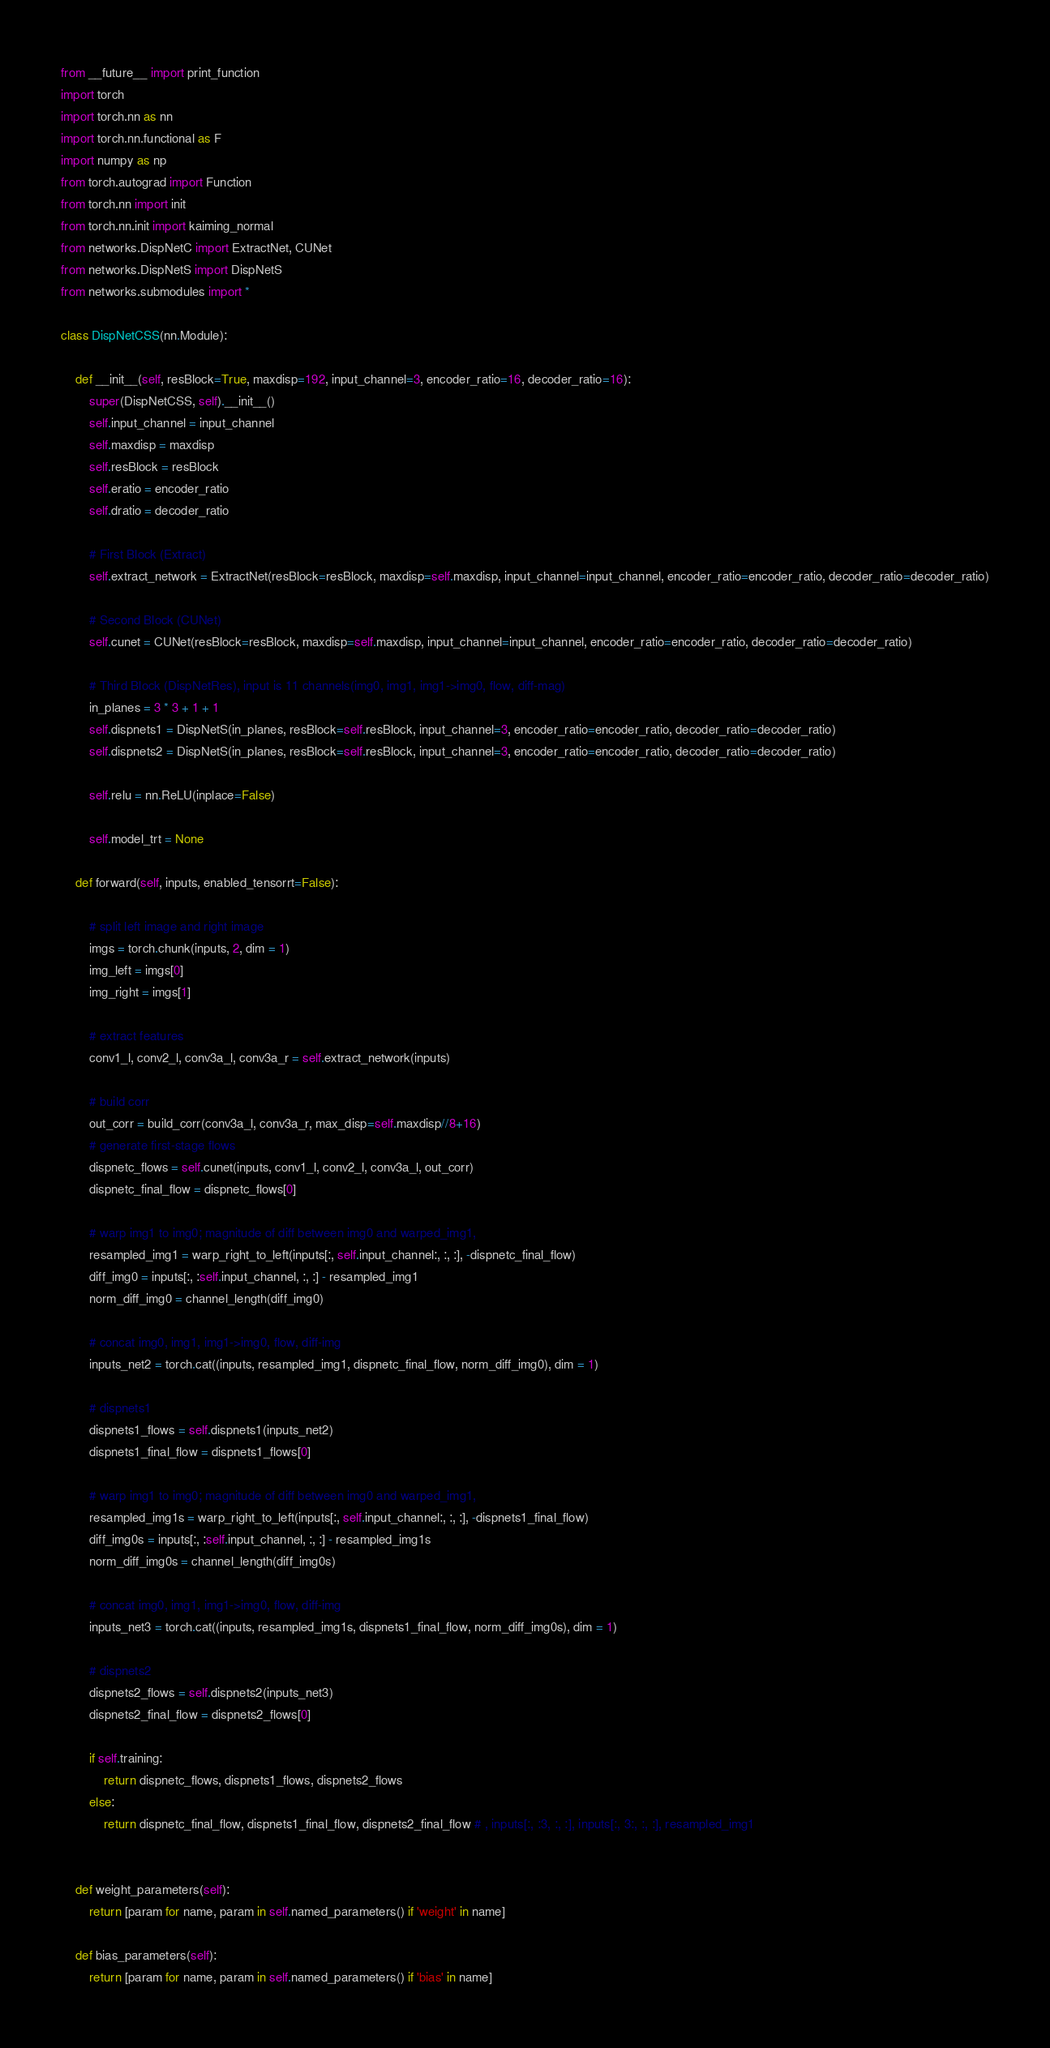Convert code to text. <code><loc_0><loc_0><loc_500><loc_500><_Python_>from __future__ import print_function
import torch
import torch.nn as nn
import torch.nn.functional as F
import numpy as np
from torch.autograd import Function
from torch.nn import init
from torch.nn.init import kaiming_normal
from networks.DispNetC import ExtractNet, CUNet
from networks.DispNetS import DispNetS
from networks.submodules import *

class DispNetCSS(nn.Module):

    def __init__(self, resBlock=True, maxdisp=192, input_channel=3, encoder_ratio=16, decoder_ratio=16):
        super(DispNetCSS, self).__init__()
        self.input_channel = input_channel
        self.maxdisp = maxdisp
        self.resBlock = resBlock
        self.eratio = encoder_ratio
        self.dratio = decoder_ratio

        # First Block (Extract)
        self.extract_network = ExtractNet(resBlock=resBlock, maxdisp=self.maxdisp, input_channel=input_channel, encoder_ratio=encoder_ratio, decoder_ratio=decoder_ratio)

        # Second Block (CUNet)
        self.cunet = CUNet(resBlock=resBlock, maxdisp=self.maxdisp, input_channel=input_channel, encoder_ratio=encoder_ratio, decoder_ratio=decoder_ratio)

        # Third Block (DispNetRes), input is 11 channels(img0, img1, img1->img0, flow, diff-mag)
        in_planes = 3 * 3 + 1 + 1
        self.dispnets1 = DispNetS(in_planes, resBlock=self.resBlock, input_channel=3, encoder_ratio=encoder_ratio, decoder_ratio=decoder_ratio)
        self.dispnets2 = DispNetS(in_planes, resBlock=self.resBlock, input_channel=3, encoder_ratio=encoder_ratio, decoder_ratio=decoder_ratio)

        self.relu = nn.ReLU(inplace=False)

        self.model_trt = None

    def forward(self, inputs, enabled_tensorrt=False):

        # split left image and right image
        imgs = torch.chunk(inputs, 2, dim = 1)
        img_left = imgs[0]
        img_right = imgs[1]

        # extract features
        conv1_l, conv2_l, conv3a_l, conv3a_r = self.extract_network(inputs)

        # build corr
        out_corr = build_corr(conv3a_l, conv3a_r, max_disp=self.maxdisp//8+16)
        # generate first-stage flows
        dispnetc_flows = self.cunet(inputs, conv1_l, conv2_l, conv3a_l, out_corr)
        dispnetc_final_flow = dispnetc_flows[0]

        # warp img1 to img0; magnitude of diff between img0 and warped_img1,
        resampled_img1 = warp_right_to_left(inputs[:, self.input_channel:, :, :], -dispnetc_final_flow)
        diff_img0 = inputs[:, :self.input_channel, :, :] - resampled_img1
        norm_diff_img0 = channel_length(diff_img0)

        # concat img0, img1, img1->img0, flow, diff-img
        inputs_net2 = torch.cat((inputs, resampled_img1, dispnetc_final_flow, norm_diff_img0), dim = 1)

        # dispnets1
        dispnets1_flows = self.dispnets1(inputs_net2)
        dispnets1_final_flow = dispnets1_flows[0]

        # warp img1 to img0; magnitude of diff between img0 and warped_img1,
        resampled_img1s = warp_right_to_left(inputs[:, self.input_channel:, :, :], -dispnets1_final_flow)
        diff_img0s = inputs[:, :self.input_channel, :, :] - resampled_img1s
        norm_diff_img0s = channel_length(diff_img0s)

        # concat img0, img1, img1->img0, flow, diff-img
        inputs_net3 = torch.cat((inputs, resampled_img1s, dispnets1_final_flow, norm_diff_img0s), dim = 1)

        # dispnets2
        dispnets2_flows = self.dispnets2(inputs_net3)
        dispnets2_final_flow = dispnets2_flows[0]

        if self.training:
            return dispnetc_flows, dispnets1_flows, dispnets2_flows
        else:
            return dispnetc_final_flow, dispnets1_final_flow, dispnets2_final_flow # , inputs[:, :3, :, :], inputs[:, 3:, :, :], resampled_img1


    def weight_parameters(self):
        return [param for name, param in self.named_parameters() if 'weight' in name]

    def bias_parameters(self):
        return [param for name, param in self.named_parameters() if 'bias' in name]


</code> 